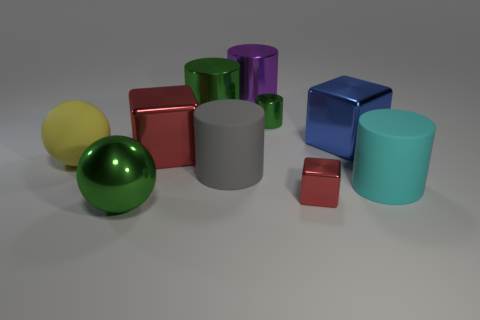Subtract all large blocks. How many blocks are left? 1 Subtract all cyan cylinders. How many red blocks are left? 2 Subtract all spheres. How many objects are left? 8 Subtract all yellow balls. How many balls are left? 1 Subtract 1 spheres. How many spheres are left? 1 Subtract 0 brown balls. How many objects are left? 10 Subtract all brown cylinders. Subtract all red spheres. How many cylinders are left? 5 Subtract all cubes. Subtract all cylinders. How many objects are left? 2 Add 7 big metallic blocks. How many big metallic blocks are left? 9 Add 3 cubes. How many cubes exist? 6 